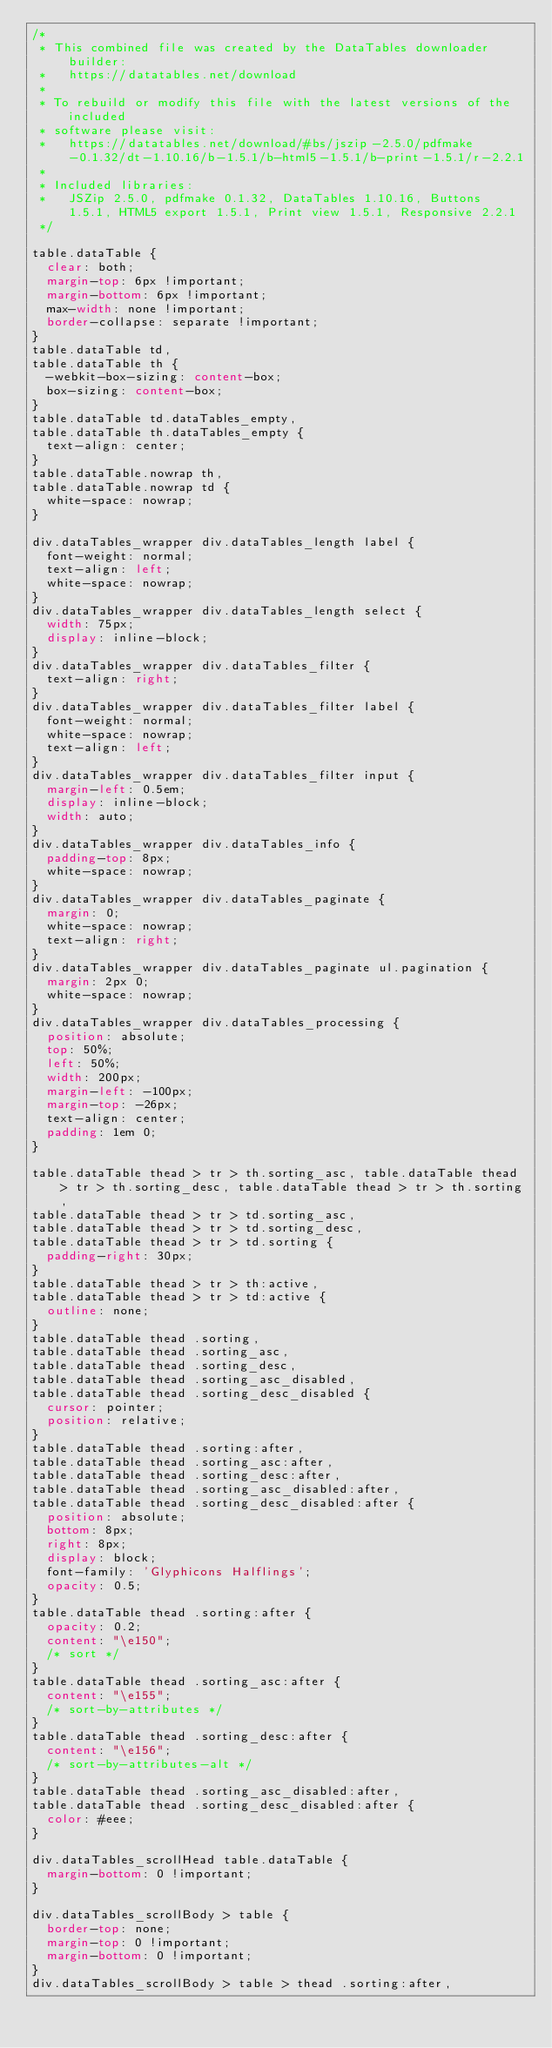<code> <loc_0><loc_0><loc_500><loc_500><_CSS_>/*
 * This combined file was created by the DataTables downloader builder:
 *   https://datatables.net/download
 *
 * To rebuild or modify this file with the latest versions of the included
 * software please visit:
 *   https://datatables.net/download/#bs/jszip-2.5.0/pdfmake-0.1.32/dt-1.10.16/b-1.5.1/b-html5-1.5.1/b-print-1.5.1/r-2.2.1
 *
 * Included libraries:
 *   JSZip 2.5.0, pdfmake 0.1.32, DataTables 1.10.16, Buttons 1.5.1, HTML5 export 1.5.1, Print view 1.5.1, Responsive 2.2.1
 */

table.dataTable {
  clear: both;
  margin-top: 6px !important;
  margin-bottom: 6px !important;
  max-width: none !important;
  border-collapse: separate !important;
}
table.dataTable td,
table.dataTable th {
  -webkit-box-sizing: content-box;
  box-sizing: content-box;
}
table.dataTable td.dataTables_empty,
table.dataTable th.dataTables_empty {
  text-align: center;
}
table.dataTable.nowrap th,
table.dataTable.nowrap td {
  white-space: nowrap;
}

div.dataTables_wrapper div.dataTables_length label {
  font-weight: normal;
  text-align: left;
  white-space: nowrap;
}
div.dataTables_wrapper div.dataTables_length select {
  width: 75px;
  display: inline-block;
}
div.dataTables_wrapper div.dataTables_filter {
  text-align: right;
}
div.dataTables_wrapper div.dataTables_filter label {
  font-weight: normal;
  white-space: nowrap;
  text-align: left;
}
div.dataTables_wrapper div.dataTables_filter input {
  margin-left: 0.5em;
  display: inline-block;
  width: auto;
}
div.dataTables_wrapper div.dataTables_info {
  padding-top: 8px;
  white-space: nowrap;
}
div.dataTables_wrapper div.dataTables_paginate {
  margin: 0;
  white-space: nowrap;
  text-align: right;
}
div.dataTables_wrapper div.dataTables_paginate ul.pagination {
  margin: 2px 0;
  white-space: nowrap;
}
div.dataTables_wrapper div.dataTables_processing {
  position: absolute;
  top: 50%;
  left: 50%;
  width: 200px;
  margin-left: -100px;
  margin-top: -26px;
  text-align: center;
  padding: 1em 0;
}

table.dataTable thead > tr > th.sorting_asc, table.dataTable thead > tr > th.sorting_desc, table.dataTable thead > tr > th.sorting,
table.dataTable thead > tr > td.sorting_asc,
table.dataTable thead > tr > td.sorting_desc,
table.dataTable thead > tr > td.sorting {
  padding-right: 30px;
}
table.dataTable thead > tr > th:active,
table.dataTable thead > tr > td:active {
  outline: none;
}
table.dataTable thead .sorting,
table.dataTable thead .sorting_asc,
table.dataTable thead .sorting_desc,
table.dataTable thead .sorting_asc_disabled,
table.dataTable thead .sorting_desc_disabled {
  cursor: pointer;
  position: relative;
}
table.dataTable thead .sorting:after,
table.dataTable thead .sorting_asc:after,
table.dataTable thead .sorting_desc:after,
table.dataTable thead .sorting_asc_disabled:after,
table.dataTable thead .sorting_desc_disabled:after {
  position: absolute;
  bottom: 8px;
  right: 8px;
  display: block;
  font-family: 'Glyphicons Halflings';
  opacity: 0.5;
}
table.dataTable thead .sorting:after {
  opacity: 0.2;
  content: "\e150";
  /* sort */
}
table.dataTable thead .sorting_asc:after {
  content: "\e155";
  /* sort-by-attributes */
}
table.dataTable thead .sorting_desc:after {
  content: "\e156";
  /* sort-by-attributes-alt */
}
table.dataTable thead .sorting_asc_disabled:after,
table.dataTable thead .sorting_desc_disabled:after {
  color: #eee;
}

div.dataTables_scrollHead table.dataTable {
  margin-bottom: 0 !important;
}

div.dataTables_scrollBody > table {
  border-top: none;
  margin-top: 0 !important;
  margin-bottom: 0 !important;
}
div.dataTables_scrollBody > table > thead .sorting:after,</code> 